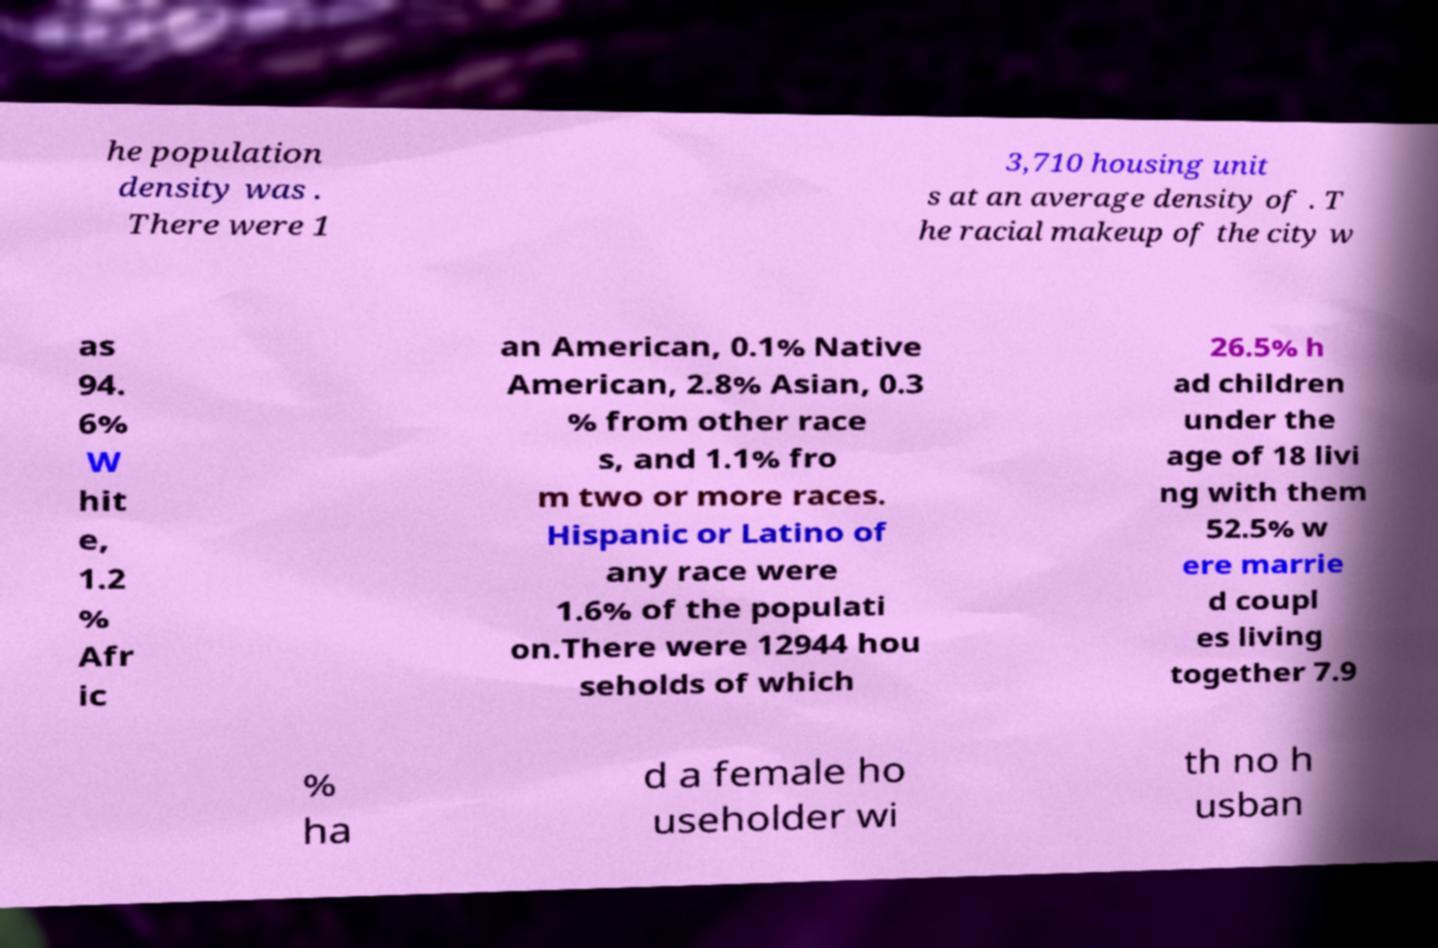Can you accurately transcribe the text from the provided image for me? he population density was . There were 1 3,710 housing unit s at an average density of . T he racial makeup of the city w as 94. 6% W hit e, 1.2 % Afr ic an American, 0.1% Native American, 2.8% Asian, 0.3 % from other race s, and 1.1% fro m two or more races. Hispanic or Latino of any race were 1.6% of the populati on.There were 12944 hou seholds of which 26.5% h ad children under the age of 18 livi ng with them 52.5% w ere marrie d coupl es living together 7.9 % ha d a female ho useholder wi th no h usban 